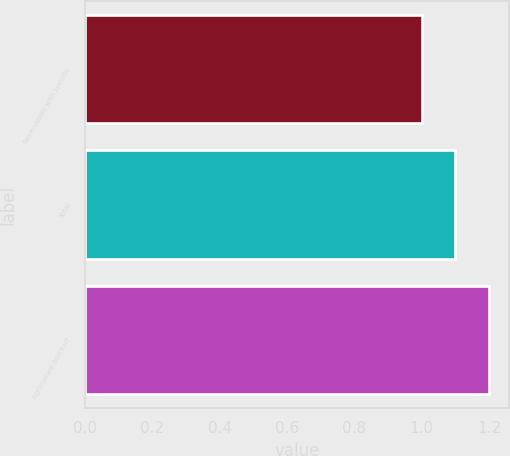Convert chart to OTSL. <chart><loc_0><loc_0><loc_500><loc_500><bar_chart><fcel>Receivables with specific<fcel>Total<fcel>Agriculture and turf<nl><fcel>1<fcel>1.1<fcel>1.2<nl></chart> 